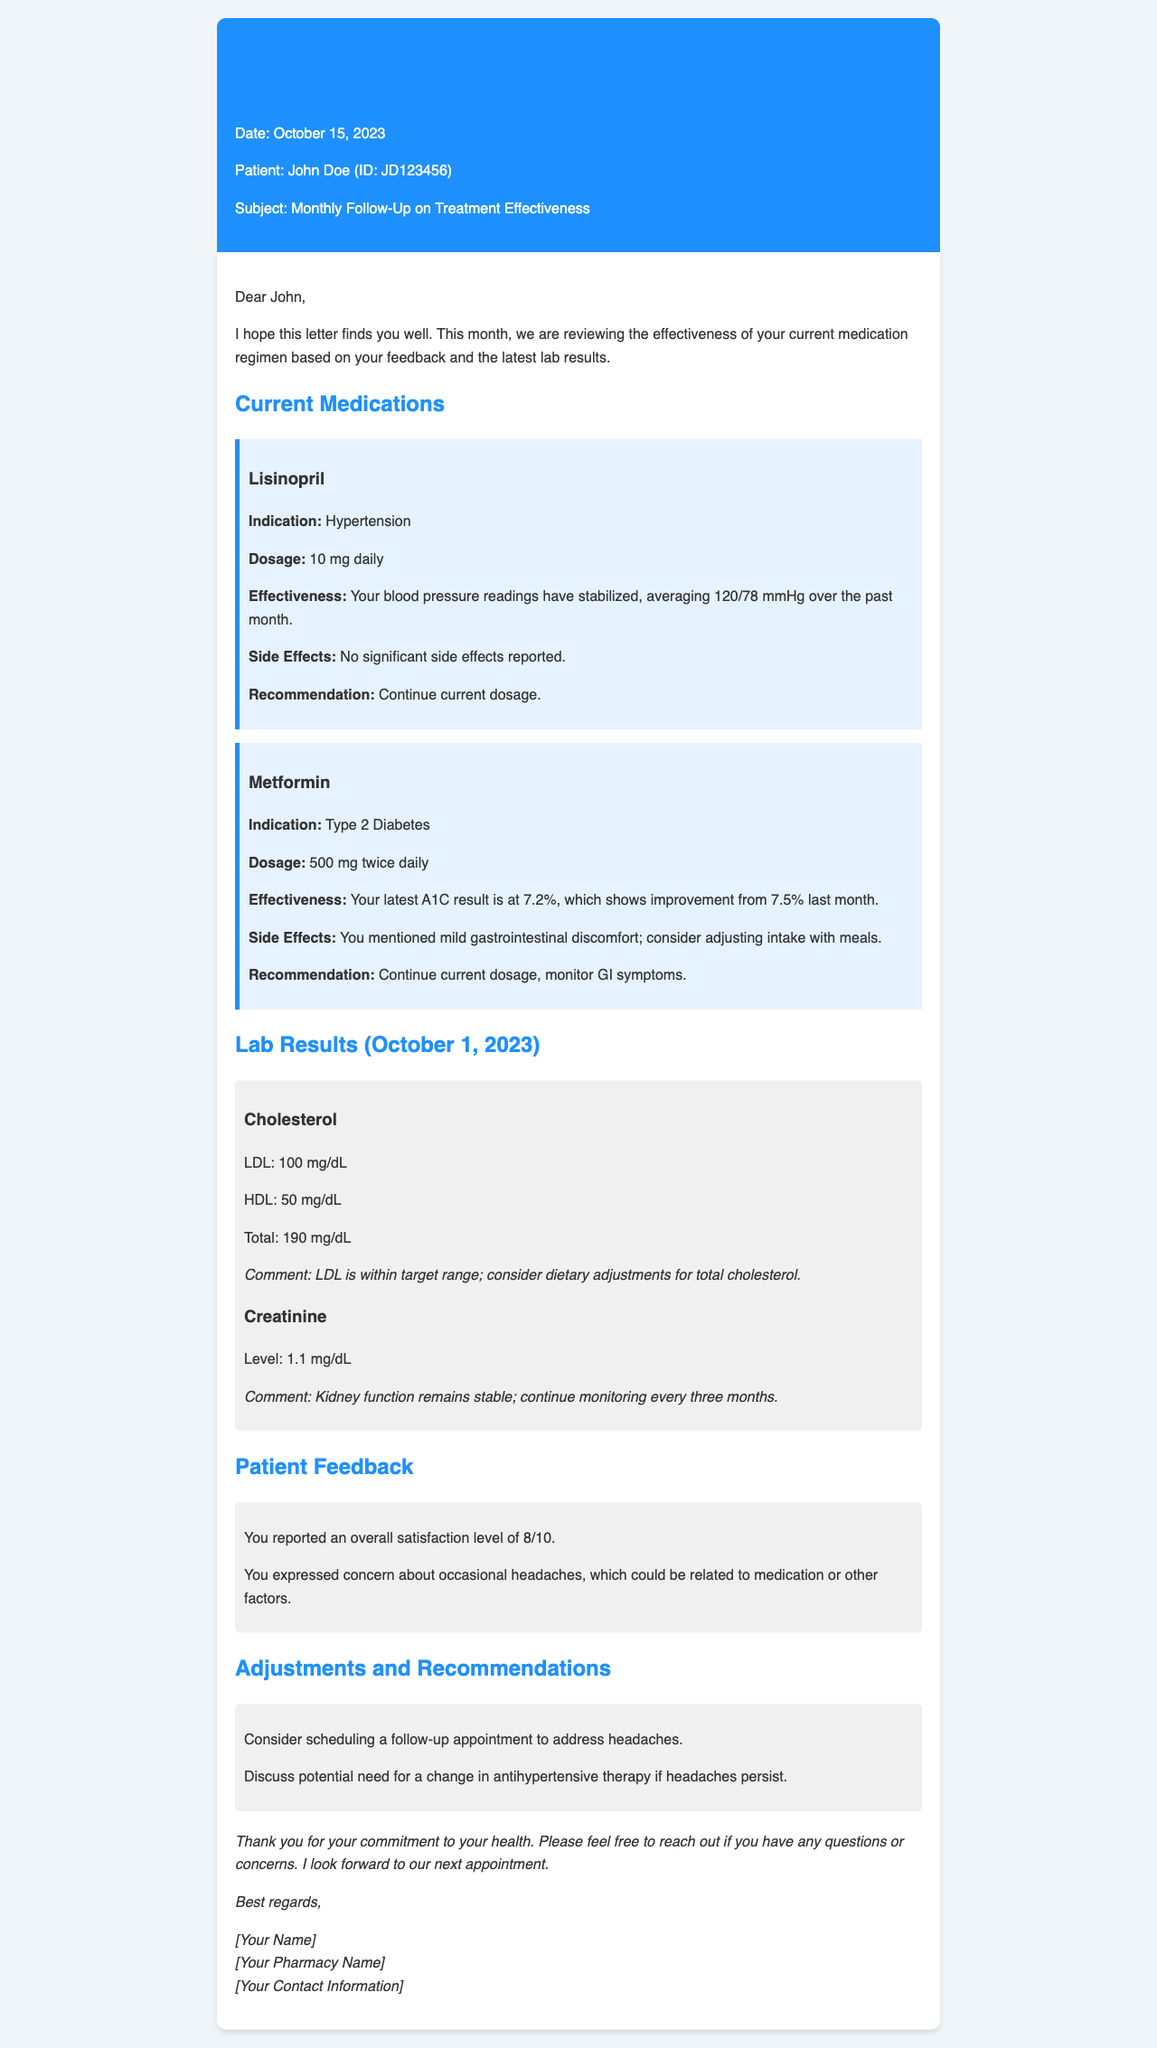what is the date of the letter? The date of the letter is mentioned in the header section.
Answer: October 15, 2023 who is the patient? The patient's name is outlined in the header of the letter.
Answer: John Doe what is the indication for Lisinopril? The indication is found in the medication section for Lisinopril.
Answer: Hypertension what was the latest A1C result? The A1C result is noted in the medication section for Metformin.
Answer: 7.2% what is the LDL cholesterol level? The LDL cholesterol level is stated in the lab results section.
Answer: 100 mg/dL how satisfied is the patient overall? The patient's satisfaction level is mentioned in the patient feedback section.
Answer: 8/10 what recommendation is made for Metformin? The recommendation for Metformin is included in the medication section.
Answer: Continue current dosage, monitor GI symptoms what should be discussed if headaches persist? This information is provided in the adjustments and recommendations section.
Answer: Change in antihypertensive therapy what are the side effects reported for Lisinopril? Side effects information for Lisinopril is described in its medication section.
Answer: No significant side effects reported 